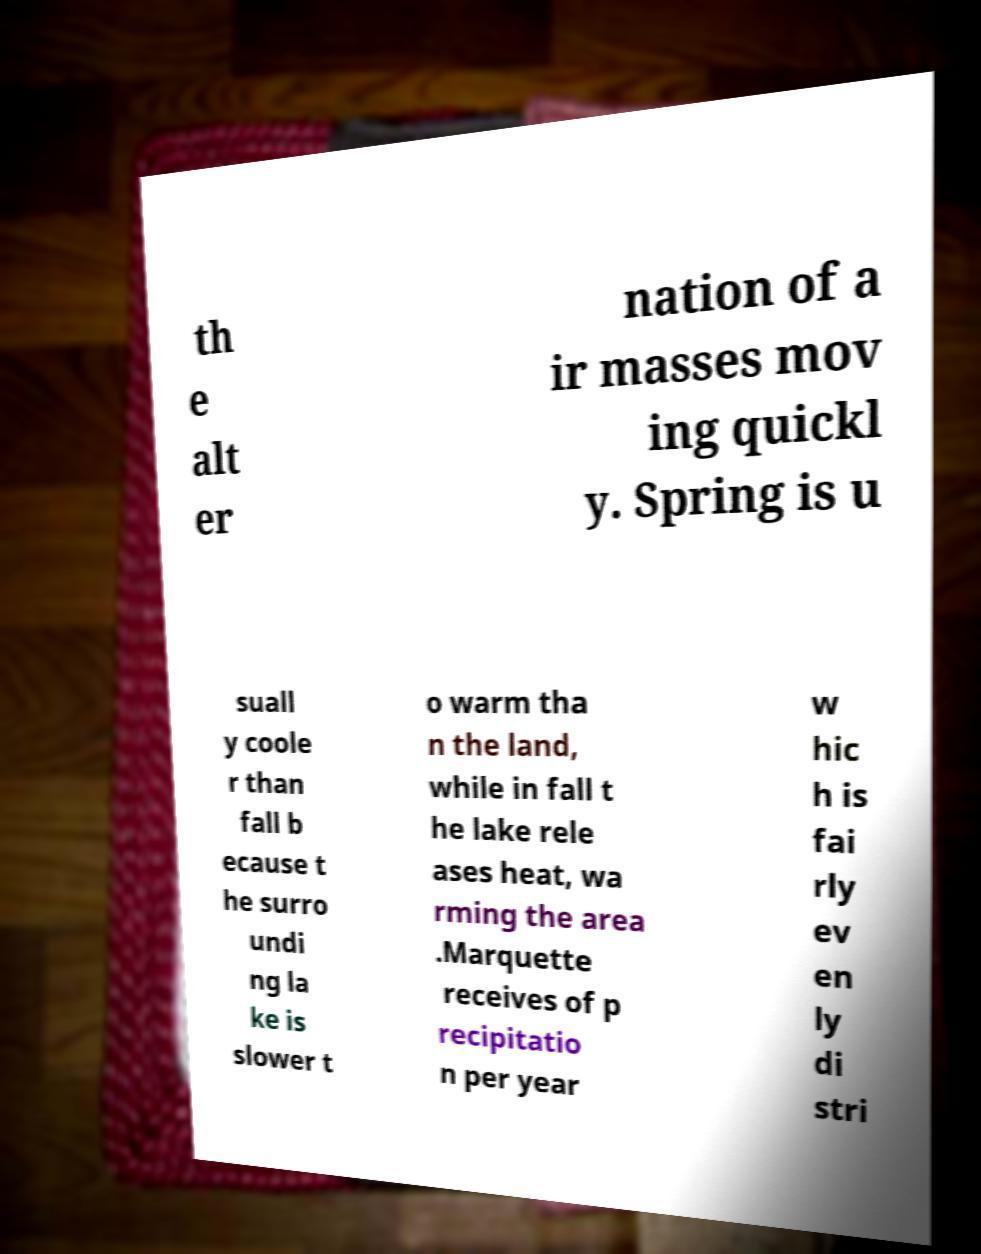For documentation purposes, I need the text within this image transcribed. Could you provide that? th e alt er nation of a ir masses mov ing quickl y. Spring is u suall y coole r than fall b ecause t he surro undi ng la ke is slower t o warm tha n the land, while in fall t he lake rele ases heat, wa rming the area .Marquette receives of p recipitatio n per year w hic h is fai rly ev en ly di stri 